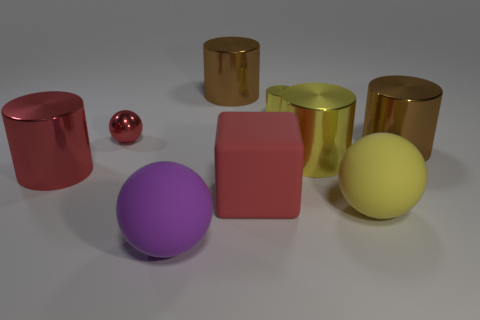How many other things are there of the same color as the big matte cube?
Your answer should be compact. 2. What is the shape of the tiny red metal thing that is in front of the small yellow metallic object?
Ensure brevity in your answer.  Sphere. How many gray objects have the same size as the rubber block?
Your answer should be compact. 0. Do the large shiny cylinder in front of the big yellow metallic thing and the small sphere have the same color?
Offer a very short reply. Yes. What material is the sphere that is left of the large yellow rubber thing and on the right side of the red metal ball?
Your answer should be very brief. Rubber. Are there more big rubber cubes than cylinders?
Provide a succinct answer. No. There is a big metal thing that is behind the big brown object right of the big brown metal cylinder that is on the left side of the cube; what color is it?
Offer a terse response. Brown. Does the large yellow object in front of the big red matte cube have the same material as the tiny red thing?
Offer a terse response. No. Is there a big rubber sphere that has the same color as the metallic ball?
Offer a very short reply. No. Are any shiny balls visible?
Offer a very short reply. Yes. 